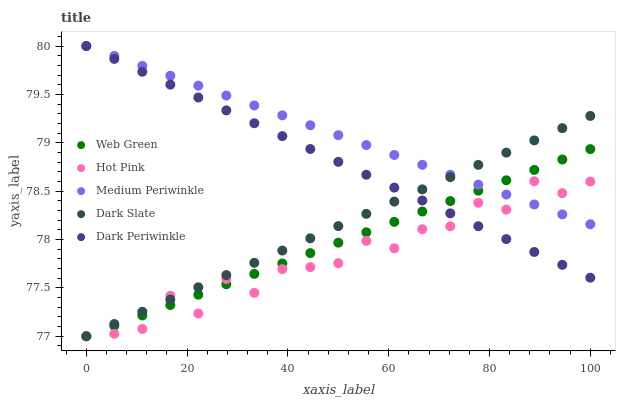Does Hot Pink have the minimum area under the curve?
Answer yes or no. Yes. Does Medium Periwinkle have the maximum area under the curve?
Answer yes or no. Yes. Does Medium Periwinkle have the minimum area under the curve?
Answer yes or no. No. Does Hot Pink have the maximum area under the curve?
Answer yes or no. No. Is Medium Periwinkle the smoothest?
Answer yes or no. Yes. Is Hot Pink the roughest?
Answer yes or no. Yes. Is Hot Pink the smoothest?
Answer yes or no. No. Is Medium Periwinkle the roughest?
Answer yes or no. No. Does Dark Slate have the lowest value?
Answer yes or no. Yes. Does Medium Periwinkle have the lowest value?
Answer yes or no. No. Does Dark Periwinkle have the highest value?
Answer yes or no. Yes. Does Hot Pink have the highest value?
Answer yes or no. No. Does Dark Periwinkle intersect Dark Slate?
Answer yes or no. Yes. Is Dark Periwinkle less than Dark Slate?
Answer yes or no. No. Is Dark Periwinkle greater than Dark Slate?
Answer yes or no. No. 